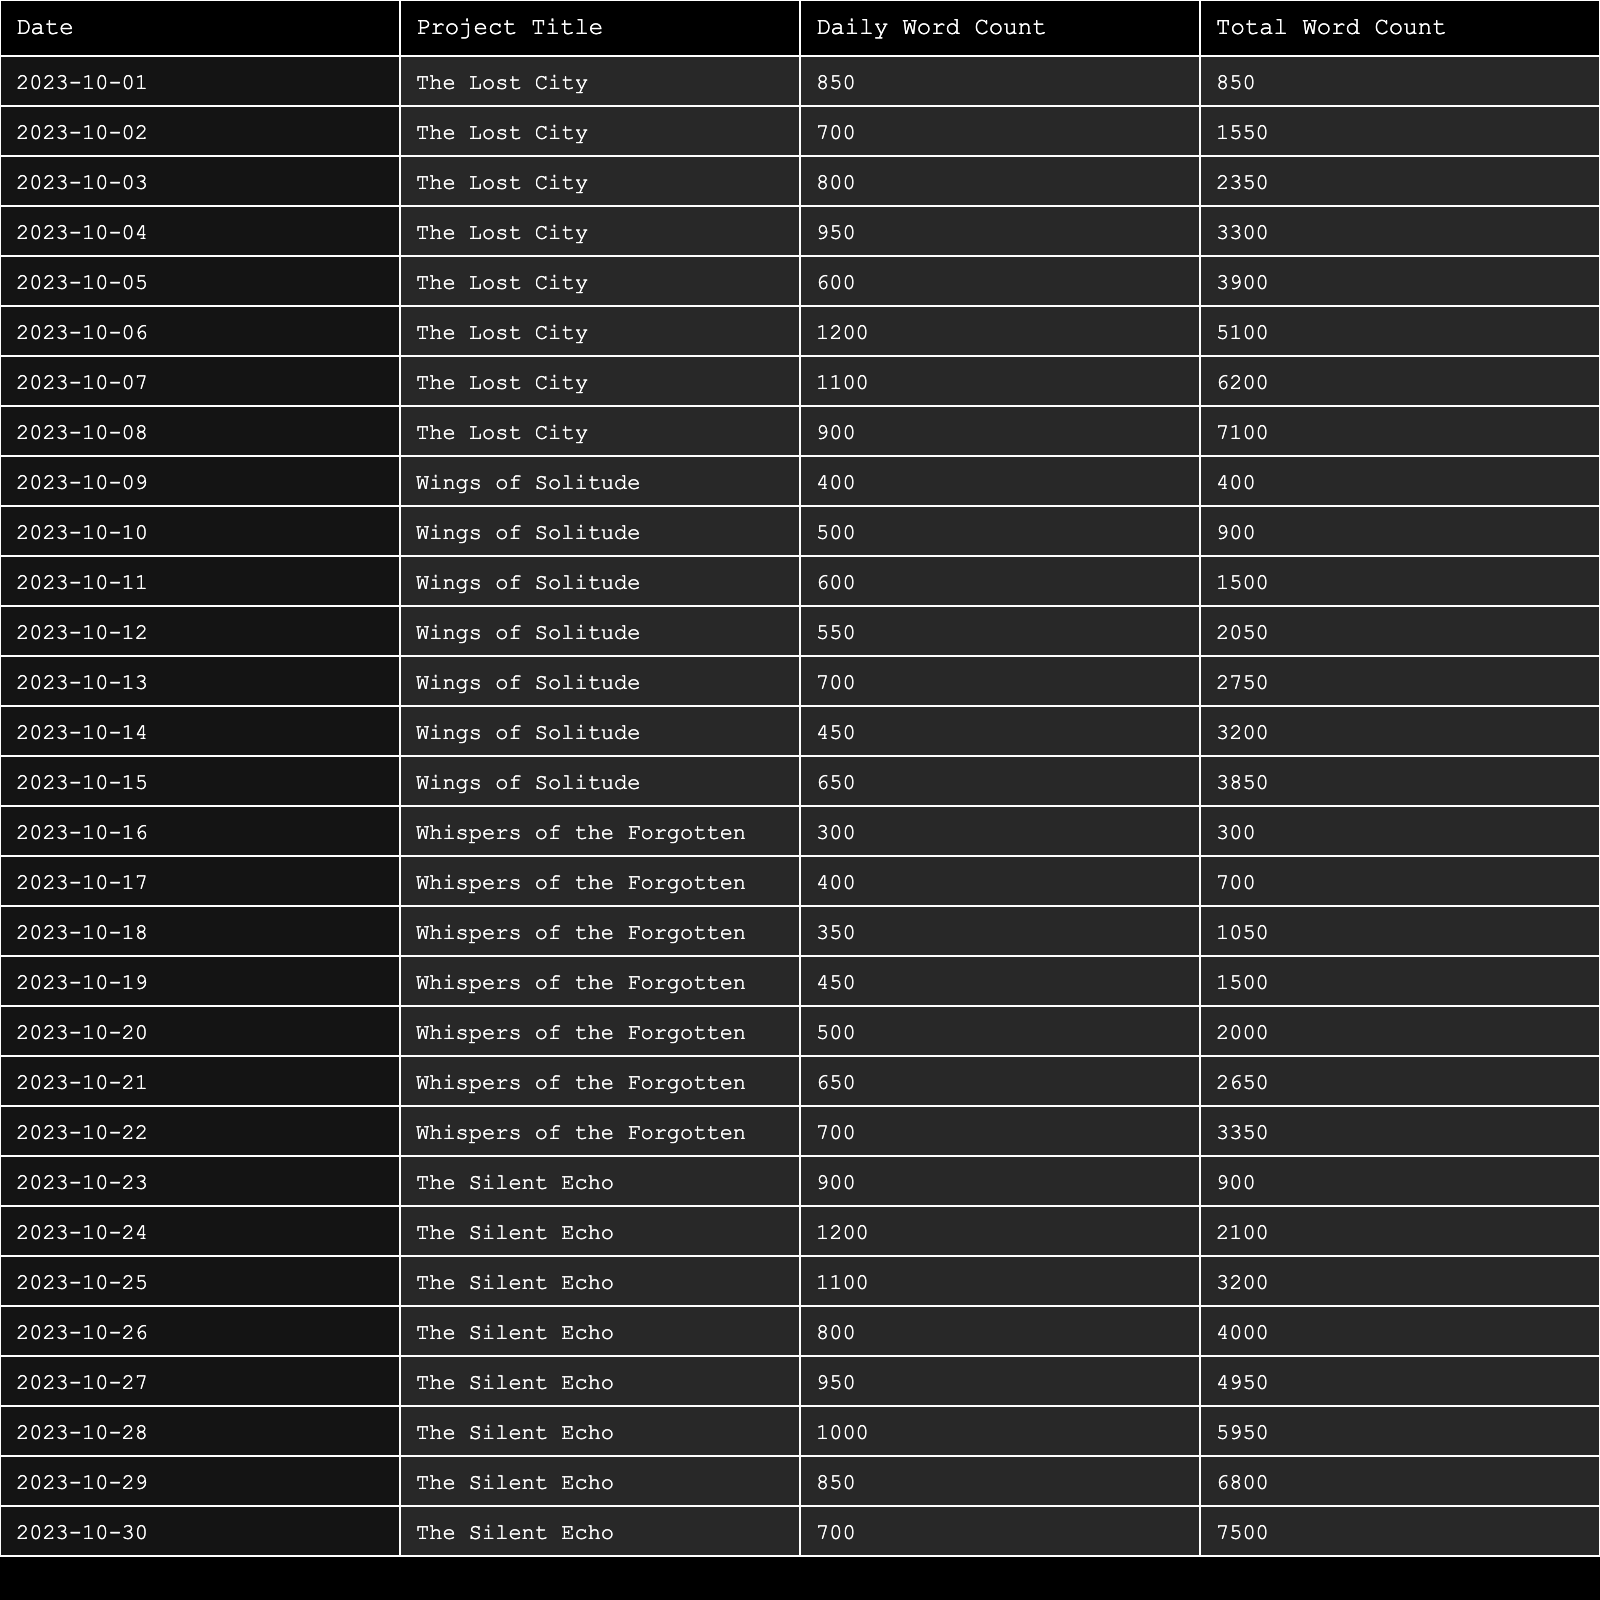What is the total word count for "The Lost City"? The table shows the total word count for "The Lost City" is listed in the last column. Referring to the last entry for "The Lost City," the total word count is 7500.
Answer: 7500 What was the daily word count on 2023-10-10 for "Wings of Solitude"? To find the daily word count on 2023-10-10 for "Wings of Solitude," I can look at the date and project in the table. On that date, the daily word count is 500.
Answer: 500 What is the average daily word count for "Whispers of the Forgotten"? Add the daily word counts for "Whispers of the Forgotten" (300 + 400 + 350 + 450 + 500 + 650 + 700 = 3350), and then divide by the number of entries (7), which gives 3350/7 ≈ 478.57.
Answer: 478.57 Did "The Silent Echo" have a daily word count above 1000 on any day? I can look at the daily word counts for "The Silent Echo." The entries for daily word counts are 900, 1200, 1100, 800, 950, 1000, 850, and 700. Since 1200 is above 1000, the answer is yes.
Answer: Yes What was the highest single-day word count recorded across all projects? I compare the daily word counts for all projects by looking through each day's entry. The highest word count is 1200 for "The Silent Echo" on 2023-10-24.
Answer: 1200 How many days did "Wings of Solitude" have a daily word count less than 500? I review the daily word counts for "Wings of Solitude" (400, 500, 600, 550, 700, 450, 650). The counts less than 500 are just 400, and 450, resulting in 2 days.
Answer: 2 What is the total word count for all projects combined? To find this, I can sum the total word counts for each project as listed in the table: (7500 + 3850 + 3350 + 2100) = 16700.
Answer: 16700 Which project had the highest total word count at the end of the recorded days? The total word counts at the end of the recorded days were 7500 for "The Silent Echo," 3900 for "The Lost City," 3850 for "Wings of Solitude," and 3350 for "Whispers of the Forgotten." The highest is for "The Silent Echo."
Answer: The Silent Echo What was the daily word count trend of “The Lost City” over the recorded days? By analyzing the daily word counts for “The Lost City,” the counts show a mixed trend, starting with an increase, peaking at 1200, and then dropping, indicating variability in writing productivity.
Answer: Mixed trend 